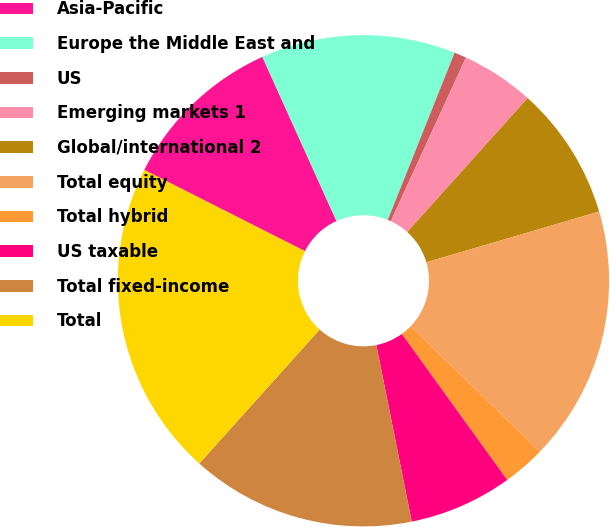Convert chart. <chart><loc_0><loc_0><loc_500><loc_500><pie_chart><fcel>Asia-Pacific<fcel>Europe the Middle East and<fcel>US<fcel>Emerging markets 1<fcel>Global/international 2<fcel>Total equity<fcel>Total hybrid<fcel>US taxable<fcel>Total fixed-income<fcel>Total<nl><fcel>10.8%<fcel>12.8%<fcel>0.8%<fcel>4.8%<fcel>8.8%<fcel>16.8%<fcel>2.8%<fcel>6.8%<fcel>14.8%<fcel>20.8%<nl></chart> 